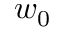Convert formula to latex. <formula><loc_0><loc_0><loc_500><loc_500>w _ { 0 }</formula> 